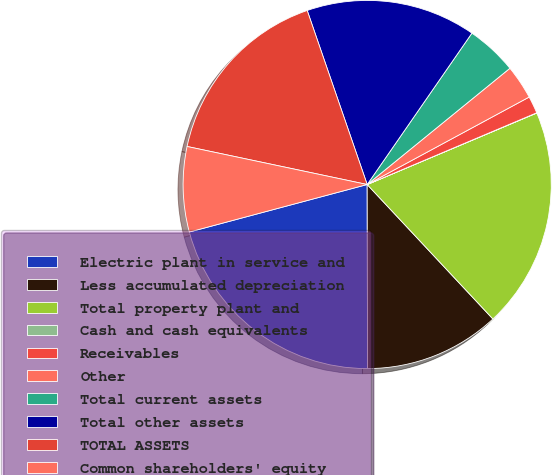Convert chart to OTSL. <chart><loc_0><loc_0><loc_500><loc_500><pie_chart><fcel>Electric plant in service and<fcel>Less accumulated depreciation<fcel>Total property plant and<fcel>Cash and cash equivalents<fcel>Receivables<fcel>Other<fcel>Total current assets<fcel>Total other assets<fcel>TOTAL ASSETS<fcel>Common shareholders' equity<nl><fcel>20.88%<fcel>11.94%<fcel>19.39%<fcel>0.02%<fcel>1.51%<fcel>3.0%<fcel>4.49%<fcel>14.92%<fcel>16.41%<fcel>7.47%<nl></chart> 